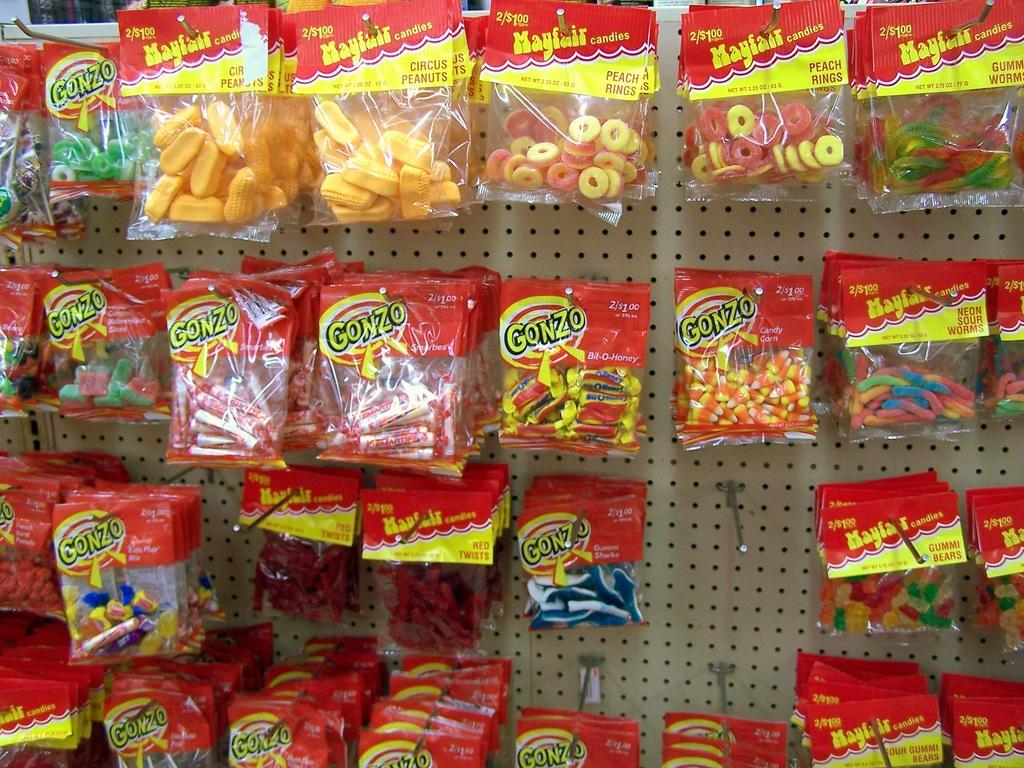What type of items are attached to the board in the image? There are many packets of candies and chocolates in the image. How are the candies and chocolates arranged on the board? The candies and chocolates are attached to the board. What type of bait is used to attract the goat in the image? There is no goat or bait present in the image; it features packets of candies and chocolates attached to a board. Can you see the ocean in the background of the image? There is no ocean visible in the image; it focuses on the board with candies and chocolates. 